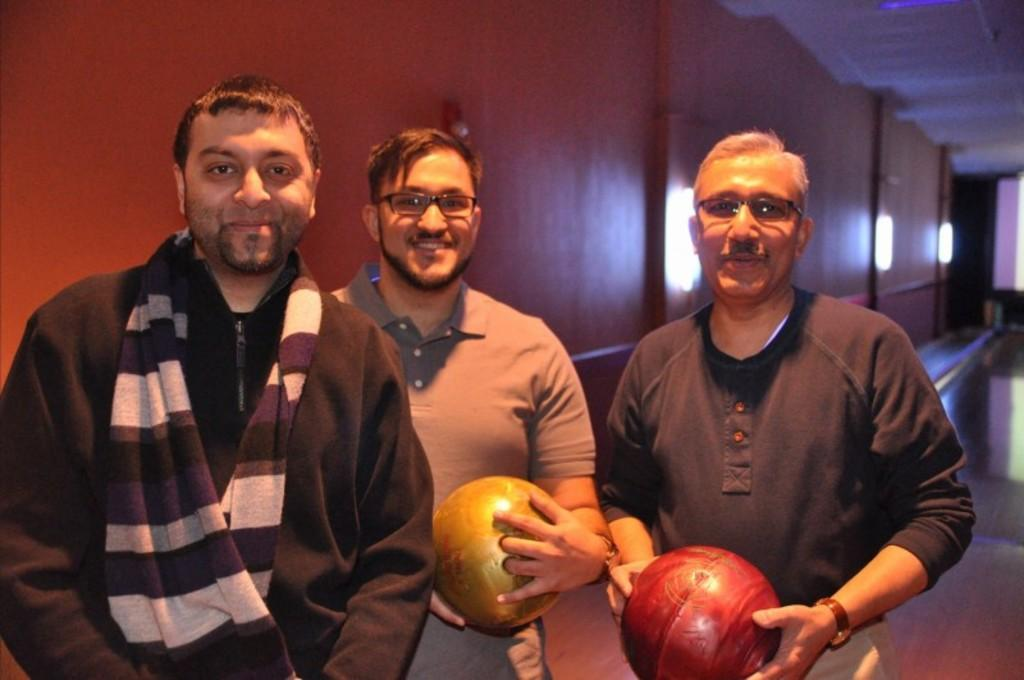How many people are in the image? There are three persons standing in the image. What are the people doing in the image? The persons are smiling and holding balls. What can be seen in the background of the image? There is a wall in the background of the image. What is the structure visible at the top right side of the image? The top right side of the image has a roof. What type of insect is crawling on the person's shoulder in the image? There is no insect present on anyone's shoulder in the image. Are the three persons in the image participating in a competition? There is no indication of a competition in the image; the persons are simply standing and holding balls. 